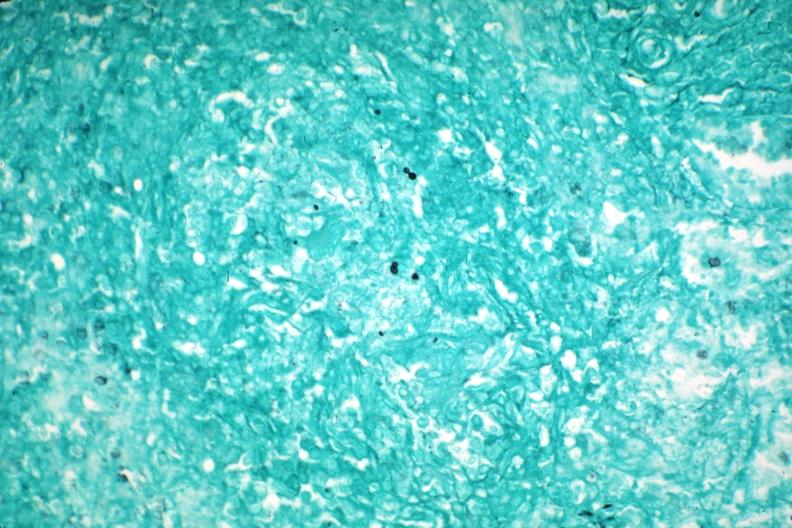s arcus senilis present?
Answer the question using a single word or phrase. No 